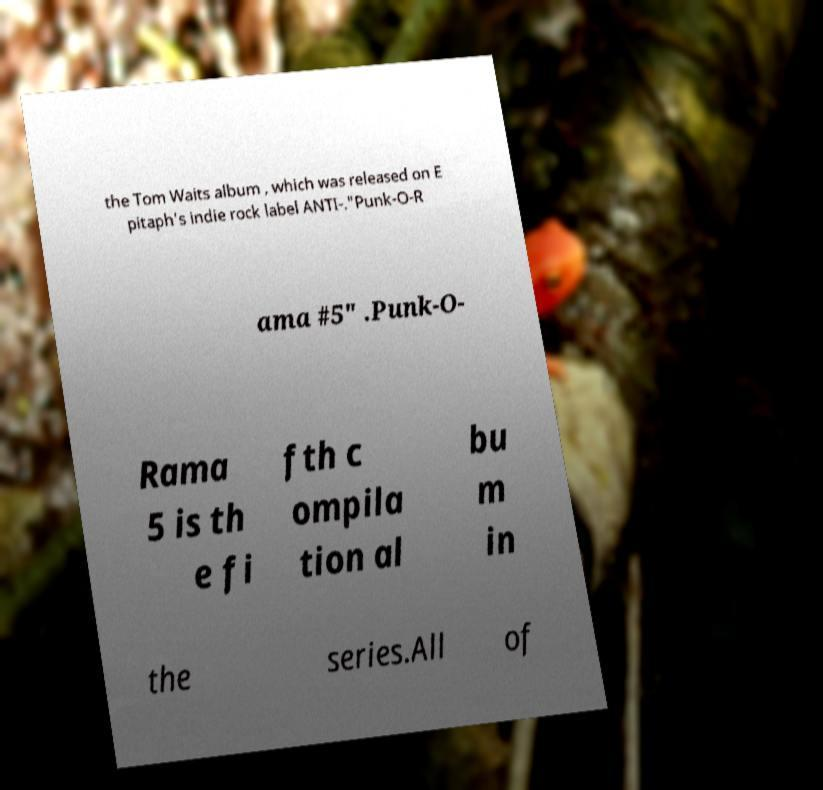What messages or text are displayed in this image? I need them in a readable, typed format. the Tom Waits album , which was released on E pitaph's indie rock label ANTI-."Punk-O-R ama #5" .Punk-O- Rama 5 is th e fi fth c ompila tion al bu m in the series.All of 